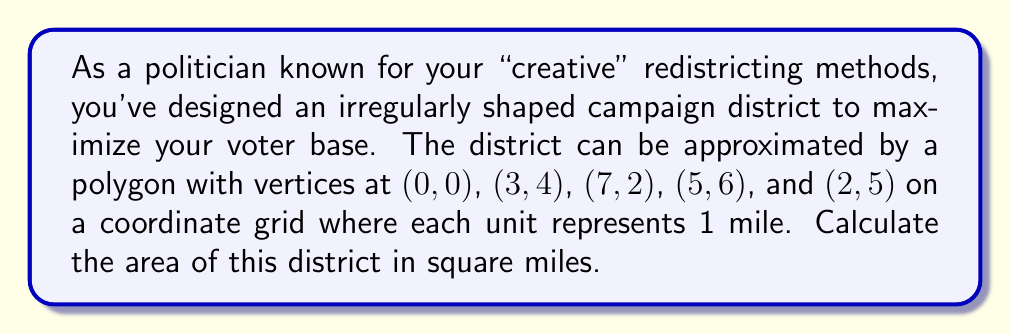Help me with this question. To calculate the area of this irregular polygon, we can use the Shoelace formula (also known as the surveyor's formula). The steps are as follows:

1) List the coordinates in order (clockwise or counterclockwise):
   $(0,0)$, $(3,4)$, $(7,2)$, $(5,6)$, $(2,5)$, $(0,0)$

2) Apply the Shoelace formula:
   $$A = \frac{1}{2}|(x_1y_2 + x_2y_3 + ... + x_ny_1) - (y_1x_2 + y_2x_3 + ... + y_nx_1)|$$

3) Substitute the values:
   $$A = \frac{1}{2}|(0 \cdot 4 + 3 \cdot 2 + 7 \cdot 6 + 5 \cdot 5 + 2 \cdot 0 + 0 \cdot 0) - (0 \cdot 3 + 4 \cdot 7 + 2 \cdot 5 + 6 \cdot 2 + 5 \cdot 0 + 0 \cdot 0)|$$

4) Simplify:
   $$A = \frac{1}{2}|(0 + 6 + 42 + 25 + 0 + 0) - (0 + 28 + 10 + 12 + 0 + 0)|$$
   $$A = \frac{1}{2}|73 - 50|$$
   $$A = \frac{1}{2} \cdot 23$$
   $$A = 11.5$$

Therefore, the area of the irregularly shaped campaign district is 11.5 square miles.
Answer: 11.5 square miles 